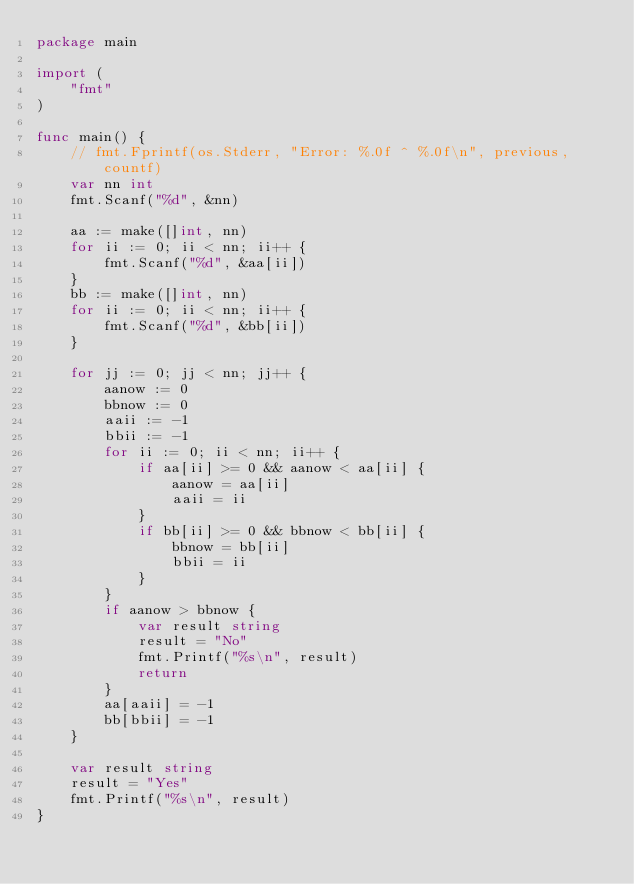<code> <loc_0><loc_0><loc_500><loc_500><_Go_>package main

import (
	"fmt"
)

func main() {
	// fmt.Fprintf(os.Stderr, "Error: %.0f ^ %.0f\n", previous, countf)
	var nn int
	fmt.Scanf("%d", &nn)

	aa := make([]int, nn)
	for ii := 0; ii < nn; ii++ {
		fmt.Scanf("%d", &aa[ii])
	}
	bb := make([]int, nn)
	for ii := 0; ii < nn; ii++ {
		fmt.Scanf("%d", &bb[ii])
	}

	for jj := 0; jj < nn; jj++ {
		aanow := 0
		bbnow := 0
		aaii := -1
		bbii := -1
		for ii := 0; ii < nn; ii++ {
			if aa[ii] >= 0 && aanow < aa[ii] {
				aanow = aa[ii]
				aaii = ii
			}
			if bb[ii] >= 0 && bbnow < bb[ii] {
				bbnow = bb[ii]
				bbii = ii
			}
		}
		if aanow > bbnow {
			var result string
			result = "No"
			fmt.Printf("%s\n", result)
			return
		}
		aa[aaii] = -1
		bb[bbii] = -1
	}

	var result string
	result = "Yes"
	fmt.Printf("%s\n", result)
}
</code> 